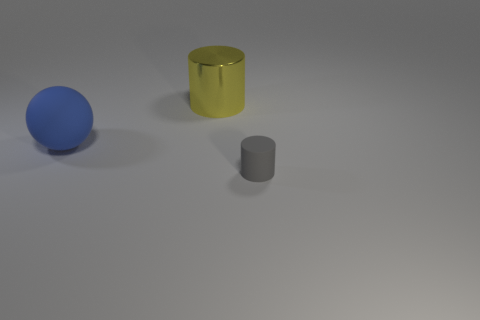How many metallic objects are big cylinders or large purple cubes?
Provide a succinct answer. 1. There is a rubber object that is on the right side of the cylinder that is behind the gray object; what size is it?
Offer a very short reply. Small. There is a thing behind the matte thing that is behind the tiny rubber object; is there a small gray matte object that is right of it?
Offer a terse response. Yes. Do the cylinder that is behind the small gray cylinder and the object that is left of the yellow metallic object have the same material?
Give a very brief answer. No. What number of objects are green matte cubes or things left of the large yellow cylinder?
Offer a very short reply. 1. How many other big shiny objects have the same shape as the shiny thing?
Keep it short and to the point. 0. There is a sphere that is the same size as the shiny object; what material is it?
Provide a succinct answer. Rubber. There is a cylinder in front of the rubber thing behind the cylinder on the right side of the large shiny object; how big is it?
Give a very brief answer. Small. Does the matte object on the right side of the large blue rubber sphere have the same color as the cylinder left of the small rubber cylinder?
Keep it short and to the point. No. How many brown objects are big matte cubes or large metal things?
Your answer should be compact. 0. 